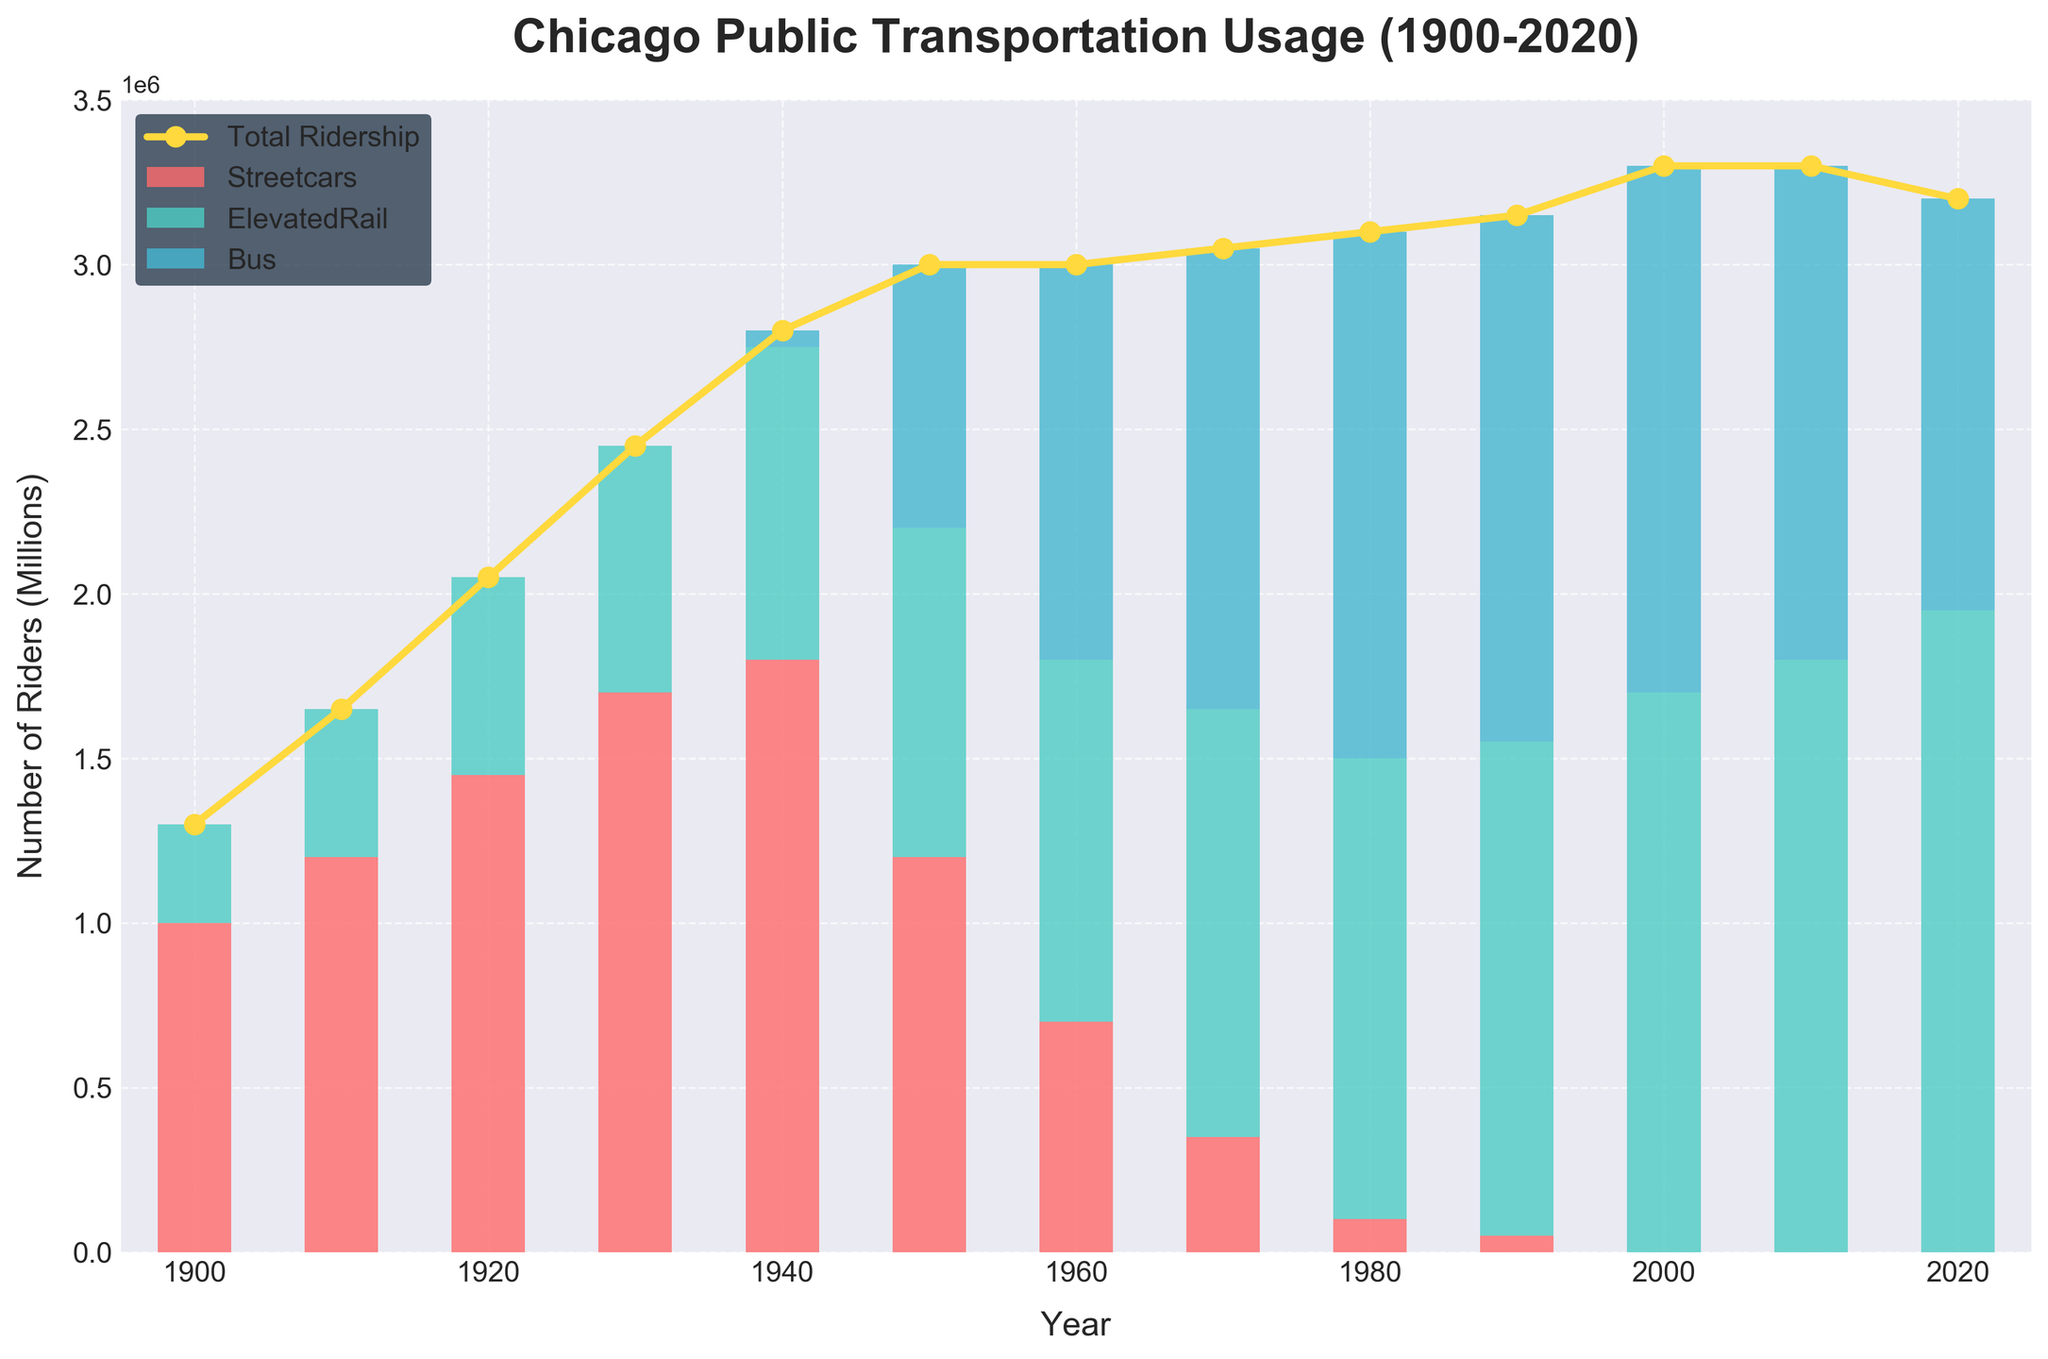What is the title of the figure? The title is normally prominently displayed at the top of the figure.
Answer: Chicago Public Transportation Usage (1900-2020) What are the modes of transportation displayed in the figure? The figure shows different segments for each mode of transportation. The labels in the legend indicate which they are.
Answer: Streetcars, Elevated Rail, Bus Between which years did streetcars completely stop being used? By tracking the bars for streetcars that drop to zero and checking the corresponding years on the x-axis.
Answer: 1990 to 2000 Which mode of transportation saw an increase in usage from 2000 onwards? By observing the bars for each mode from 2000 onwards, we can see which one is increasing.
Answer: Elevated Rail How does the total ridership trend change from 1900 to 2020? Following the total ridership line across the years and noting its direction can help identify the trend.
Answer: It increases What was the highest total ridership recorded, and in which year did this occur? The total ridership is indicated by a plot line, and the peak point on this line should show the highest ridership and the corresponding year.
Answer: 3300000 in 2000 and 2010 By how many million did bus ridership increase between 1940 and 1950? Check the bar height for buses in 1940 and 1950 and take the difference. This may require some estimation based on the graph's scale.
Answer: 750000 Which mode of transportation had a consistent yearly increase from 1960 until 2020? Visually inspect each year's bar for each mode. The mode that consistently shows increasing height each year is the answer.
Answer: Elevated Rail How did bus ridership in 1980 compare to that in 1970? Look at the bar heights for buses for those two years and compare them directly.
Answer: It increased What significant shift occurred in Chicago public transportation usage around the 1950s? Look for any noticeable change in the bar heights of different modes around the 1950s, reflective of a shift in transportation usage.
Answer: A shift from streetcars to buses and elevated rail 